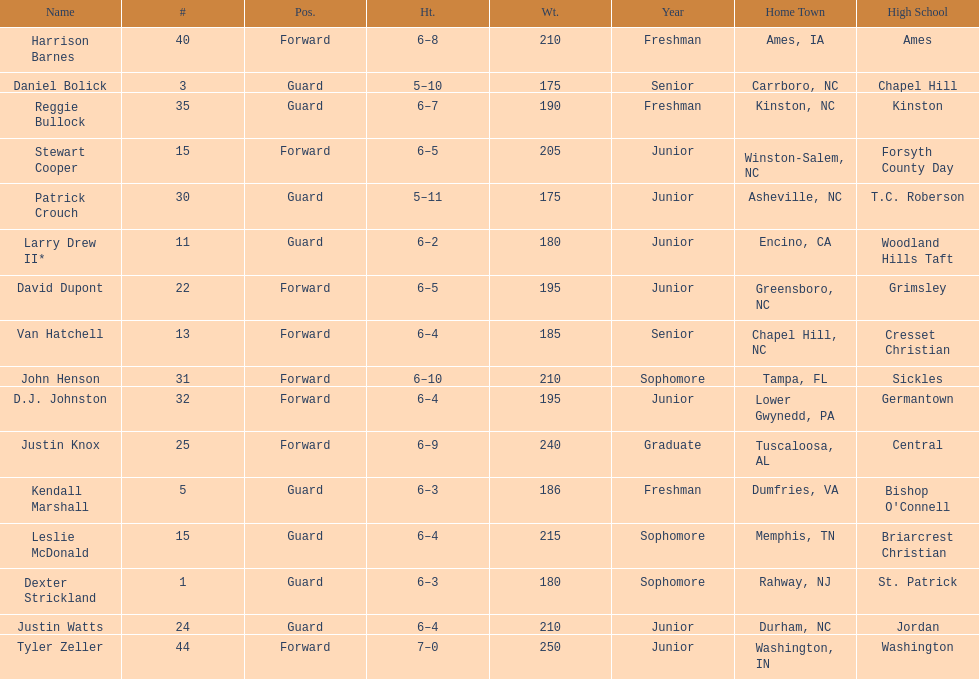What is the number of players with a weight over 200? 7. 